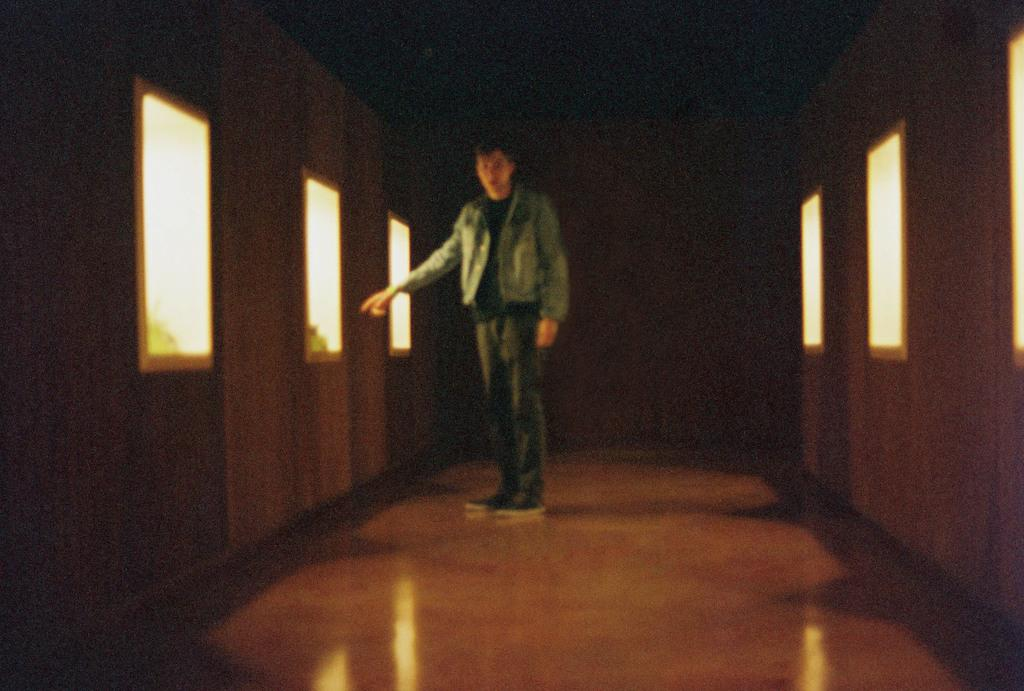What is the main subject in the center of the image? There is a boy in the center of the image. What can be seen on the sides of the image? There appear to be windows on the right and left sides of the image. Can you describe the ray of light shining through the windows in the image? There is no ray of light shining through the windows in the image; it only shows a boy and windows on the sides. 